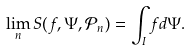<formula> <loc_0><loc_0><loc_500><loc_500>\lim _ { n } S ( f , \Psi , \mathcal { P } _ { n } ) = \int _ { I } f d \Psi .</formula> 